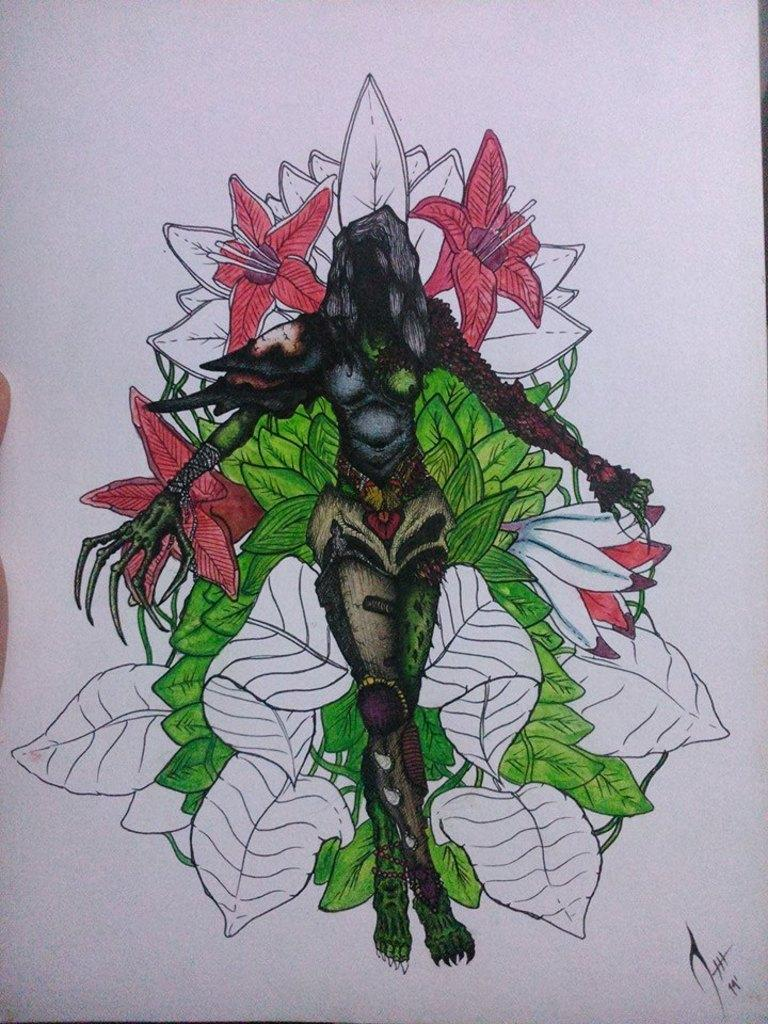What is the main object in the image? There is a white paper in the image. What is depicted on the white paper? There is a drawing on the paper. What colors are used in the drawing? The colors of the drawing are green, black, and orange. What type of writing can be seen on the coast in the image? There is no coast or writing present in the image; it features a white paper with a drawing on it. 